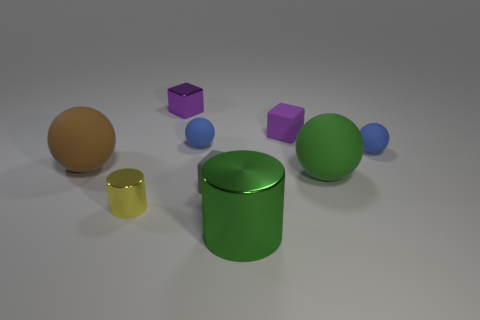Is the material of the yellow object the same as the small gray thing?
Provide a succinct answer. No. How many other things have the same material as the large brown object?
Your answer should be compact. 5. Is the size of the purple rubber thing the same as the shiny cylinder that is on the right side of the purple metal object?
Keep it short and to the point. No. What is the color of the large object that is on the left side of the big green matte object and behind the yellow thing?
Keep it short and to the point. Brown. Are there any brown rubber balls that are right of the small blue matte sphere on the left side of the green cylinder?
Offer a terse response. No. Is the number of small objects that are to the right of the big cylinder the same as the number of cubes?
Make the answer very short. No. There is a shiny cylinder that is on the right side of the blue rubber ball that is on the left side of the green matte sphere; how many tiny yellow things are behind it?
Offer a very short reply. 1. Are there any purple spheres of the same size as the gray cube?
Your answer should be compact. No. Are there fewer purple shiny blocks that are in front of the small yellow cylinder than yellow metallic cylinders?
Provide a succinct answer. Yes. What is the material of the cylinder right of the tiny blue matte ball behind the rubber ball right of the green matte sphere?
Offer a very short reply. Metal. 